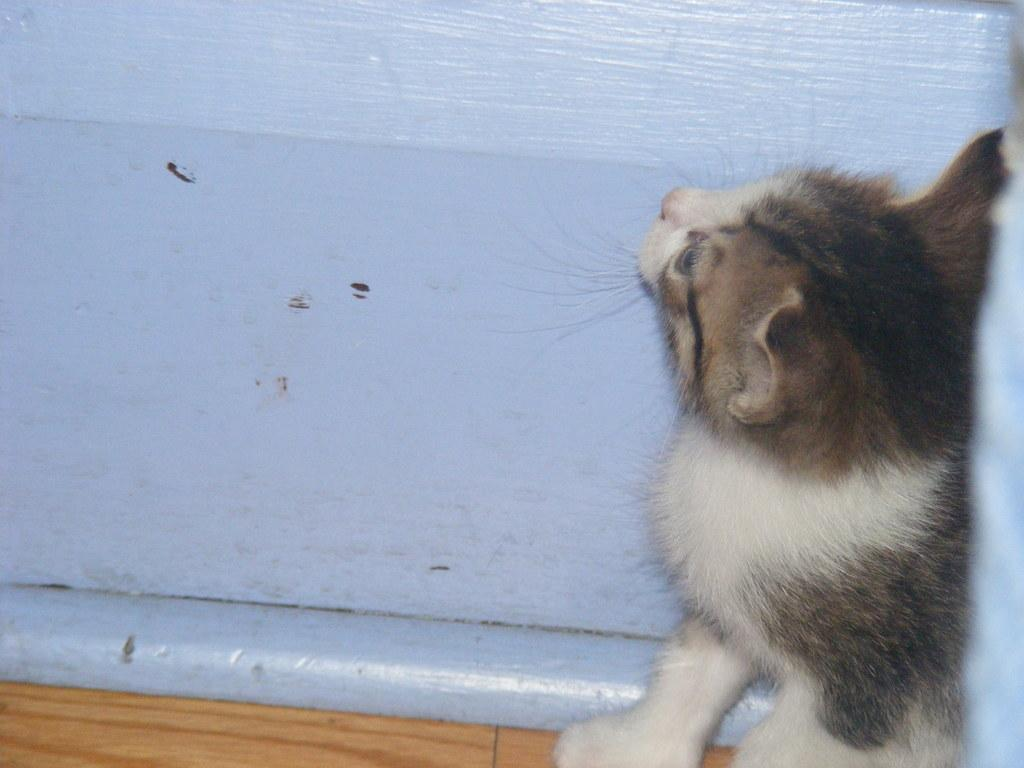What type of animal is present in the image? There is a cat in the image. What can be seen in the background of the image? There is a wall in the background of the image. What type of hair can be seen on the cat's arm in the image? There is no cat's arm present in the image, and the cat does not have hair on its arms. 